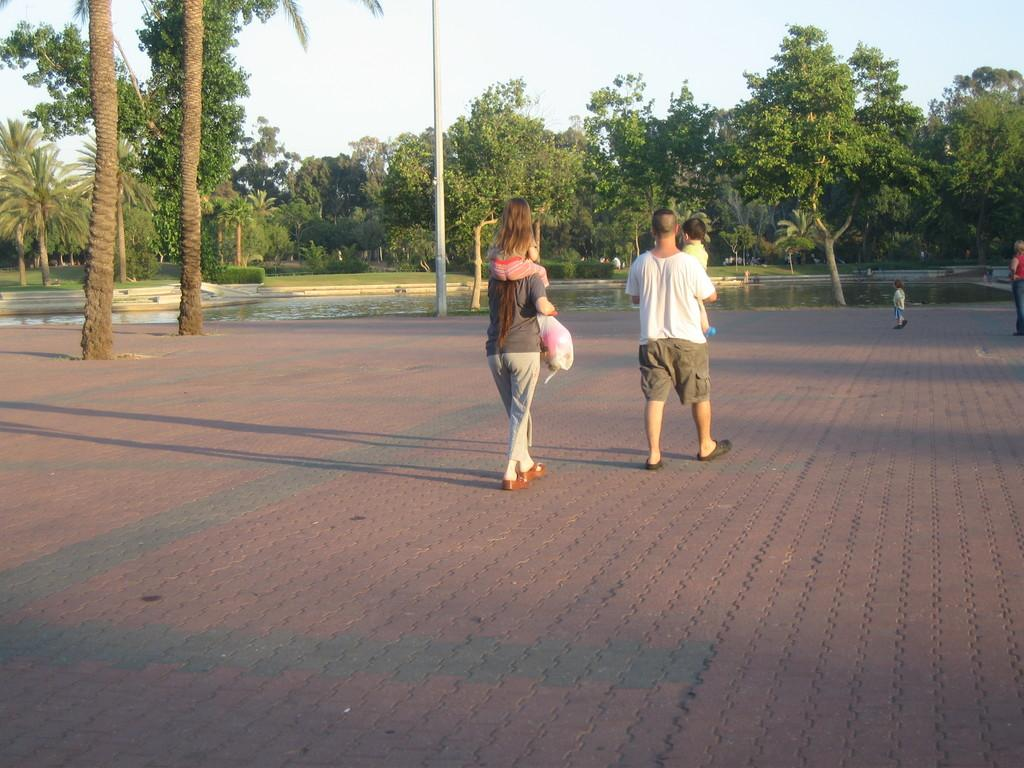What are the people in the image doing? The people in the image are walking. What are the people wearing on their feet? The people are wearing shoes. What type of surface are the people walking on? There is a footpath in the image. What can be seen in the background of the image? There is water, trees, a pole, grass, and a plant visible in the image. What is the color of the sky in the image? The sky is white in the image. What type of fruit is being used as a weapon in the battle depicted in the image? There is no battle or fruit present in the image; it features people walking on a footpath with various background elements. What is causing the people in the image to have sore throats? There is no indication in the image that the people are experiencing sore throats or any other health issues. 